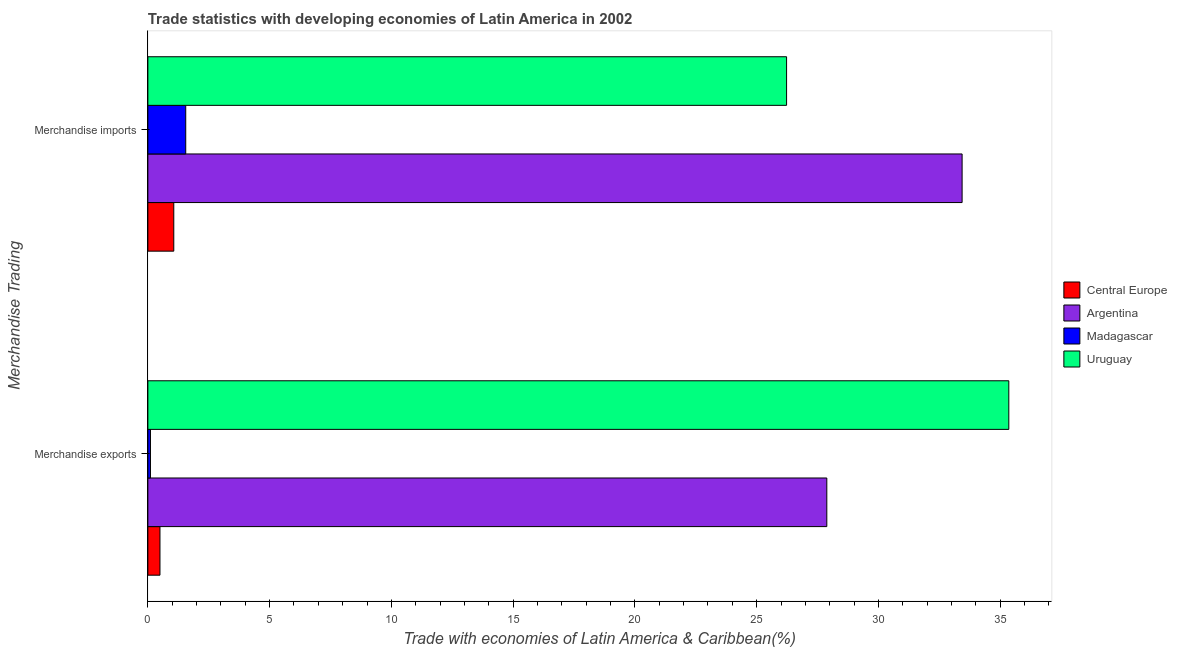How many bars are there on the 1st tick from the bottom?
Provide a short and direct response. 4. What is the label of the 2nd group of bars from the top?
Provide a short and direct response. Merchandise exports. What is the merchandise imports in Central Europe?
Offer a terse response. 1.06. Across all countries, what is the maximum merchandise exports?
Give a very brief answer. 35.35. Across all countries, what is the minimum merchandise exports?
Your answer should be compact. 0.11. In which country was the merchandise exports maximum?
Offer a very short reply. Uruguay. In which country was the merchandise exports minimum?
Give a very brief answer. Madagascar. What is the total merchandise imports in the graph?
Your answer should be compact. 62.28. What is the difference between the merchandise imports in Madagascar and that in Central Europe?
Ensure brevity in your answer.  0.49. What is the difference between the merchandise exports in Argentina and the merchandise imports in Uruguay?
Make the answer very short. 1.65. What is the average merchandise exports per country?
Offer a very short reply. 15.96. What is the difference between the merchandise imports and merchandise exports in Argentina?
Provide a short and direct response. 5.56. What is the ratio of the merchandise imports in Central Europe to that in Argentina?
Your response must be concise. 0.03. Is the merchandise exports in Central Europe less than that in Argentina?
Give a very brief answer. Yes. In how many countries, is the merchandise imports greater than the average merchandise imports taken over all countries?
Keep it short and to the point. 2. What does the 1st bar from the top in Merchandise exports represents?
Provide a short and direct response. Uruguay. What does the 4th bar from the bottom in Merchandise imports represents?
Your response must be concise. Uruguay. How many bars are there?
Your answer should be compact. 8. Are all the bars in the graph horizontal?
Keep it short and to the point. Yes. How many countries are there in the graph?
Make the answer very short. 4. What is the difference between two consecutive major ticks on the X-axis?
Give a very brief answer. 5. Does the graph contain grids?
Ensure brevity in your answer.  No. Where does the legend appear in the graph?
Your answer should be compact. Center right. What is the title of the graph?
Your response must be concise. Trade statistics with developing economies of Latin America in 2002. Does "Sub-Saharan Africa (developing only)" appear as one of the legend labels in the graph?
Offer a terse response. No. What is the label or title of the X-axis?
Offer a terse response. Trade with economies of Latin America & Caribbean(%). What is the label or title of the Y-axis?
Make the answer very short. Merchandise Trading. What is the Trade with economies of Latin America & Caribbean(%) in Central Europe in Merchandise exports?
Your answer should be very brief. 0.5. What is the Trade with economies of Latin America & Caribbean(%) of Argentina in Merchandise exports?
Make the answer very short. 27.88. What is the Trade with economies of Latin America & Caribbean(%) of Madagascar in Merchandise exports?
Make the answer very short. 0.11. What is the Trade with economies of Latin America & Caribbean(%) of Uruguay in Merchandise exports?
Provide a short and direct response. 35.35. What is the Trade with economies of Latin America & Caribbean(%) in Central Europe in Merchandise imports?
Your answer should be very brief. 1.06. What is the Trade with economies of Latin America & Caribbean(%) in Argentina in Merchandise imports?
Provide a short and direct response. 33.44. What is the Trade with economies of Latin America & Caribbean(%) in Madagascar in Merchandise imports?
Offer a terse response. 1.56. What is the Trade with economies of Latin America & Caribbean(%) in Uruguay in Merchandise imports?
Your response must be concise. 26.23. Across all Merchandise Trading, what is the maximum Trade with economies of Latin America & Caribbean(%) of Central Europe?
Offer a very short reply. 1.06. Across all Merchandise Trading, what is the maximum Trade with economies of Latin America & Caribbean(%) of Argentina?
Your response must be concise. 33.44. Across all Merchandise Trading, what is the maximum Trade with economies of Latin America & Caribbean(%) in Madagascar?
Your response must be concise. 1.56. Across all Merchandise Trading, what is the maximum Trade with economies of Latin America & Caribbean(%) of Uruguay?
Your response must be concise. 35.35. Across all Merchandise Trading, what is the minimum Trade with economies of Latin America & Caribbean(%) in Central Europe?
Ensure brevity in your answer.  0.5. Across all Merchandise Trading, what is the minimum Trade with economies of Latin America & Caribbean(%) in Argentina?
Your response must be concise. 27.88. Across all Merchandise Trading, what is the minimum Trade with economies of Latin America & Caribbean(%) of Madagascar?
Your answer should be compact. 0.11. Across all Merchandise Trading, what is the minimum Trade with economies of Latin America & Caribbean(%) in Uruguay?
Your answer should be very brief. 26.23. What is the total Trade with economies of Latin America & Caribbean(%) of Central Europe in the graph?
Make the answer very short. 1.56. What is the total Trade with economies of Latin America & Caribbean(%) in Argentina in the graph?
Provide a succinct answer. 61.32. What is the total Trade with economies of Latin America & Caribbean(%) of Madagascar in the graph?
Make the answer very short. 1.66. What is the total Trade with economies of Latin America & Caribbean(%) of Uruguay in the graph?
Your response must be concise. 61.58. What is the difference between the Trade with economies of Latin America & Caribbean(%) in Central Europe in Merchandise exports and that in Merchandise imports?
Make the answer very short. -0.57. What is the difference between the Trade with economies of Latin America & Caribbean(%) in Argentina in Merchandise exports and that in Merchandise imports?
Keep it short and to the point. -5.56. What is the difference between the Trade with economies of Latin America & Caribbean(%) of Madagascar in Merchandise exports and that in Merchandise imports?
Your response must be concise. -1.45. What is the difference between the Trade with economies of Latin America & Caribbean(%) in Uruguay in Merchandise exports and that in Merchandise imports?
Your response must be concise. 9.13. What is the difference between the Trade with economies of Latin America & Caribbean(%) in Central Europe in Merchandise exports and the Trade with economies of Latin America & Caribbean(%) in Argentina in Merchandise imports?
Your answer should be very brief. -32.94. What is the difference between the Trade with economies of Latin America & Caribbean(%) in Central Europe in Merchandise exports and the Trade with economies of Latin America & Caribbean(%) in Madagascar in Merchandise imports?
Your answer should be very brief. -1.06. What is the difference between the Trade with economies of Latin America & Caribbean(%) in Central Europe in Merchandise exports and the Trade with economies of Latin America & Caribbean(%) in Uruguay in Merchandise imports?
Offer a very short reply. -25.73. What is the difference between the Trade with economies of Latin America & Caribbean(%) of Argentina in Merchandise exports and the Trade with economies of Latin America & Caribbean(%) of Madagascar in Merchandise imports?
Offer a terse response. 26.32. What is the difference between the Trade with economies of Latin America & Caribbean(%) in Argentina in Merchandise exports and the Trade with economies of Latin America & Caribbean(%) in Uruguay in Merchandise imports?
Your answer should be very brief. 1.65. What is the difference between the Trade with economies of Latin America & Caribbean(%) of Madagascar in Merchandise exports and the Trade with economies of Latin America & Caribbean(%) of Uruguay in Merchandise imports?
Your answer should be very brief. -26.12. What is the average Trade with economies of Latin America & Caribbean(%) in Central Europe per Merchandise Trading?
Give a very brief answer. 0.78. What is the average Trade with economies of Latin America & Caribbean(%) of Argentina per Merchandise Trading?
Your response must be concise. 30.66. What is the average Trade with economies of Latin America & Caribbean(%) of Madagascar per Merchandise Trading?
Offer a terse response. 0.83. What is the average Trade with economies of Latin America & Caribbean(%) of Uruguay per Merchandise Trading?
Make the answer very short. 30.79. What is the difference between the Trade with economies of Latin America & Caribbean(%) of Central Europe and Trade with economies of Latin America & Caribbean(%) of Argentina in Merchandise exports?
Make the answer very short. -27.38. What is the difference between the Trade with economies of Latin America & Caribbean(%) in Central Europe and Trade with economies of Latin America & Caribbean(%) in Madagascar in Merchandise exports?
Offer a terse response. 0.39. What is the difference between the Trade with economies of Latin America & Caribbean(%) of Central Europe and Trade with economies of Latin America & Caribbean(%) of Uruguay in Merchandise exports?
Give a very brief answer. -34.86. What is the difference between the Trade with economies of Latin America & Caribbean(%) of Argentina and Trade with economies of Latin America & Caribbean(%) of Madagascar in Merchandise exports?
Offer a very short reply. 27.77. What is the difference between the Trade with economies of Latin America & Caribbean(%) of Argentina and Trade with economies of Latin America & Caribbean(%) of Uruguay in Merchandise exports?
Offer a very short reply. -7.47. What is the difference between the Trade with economies of Latin America & Caribbean(%) of Madagascar and Trade with economies of Latin America & Caribbean(%) of Uruguay in Merchandise exports?
Provide a succinct answer. -35.25. What is the difference between the Trade with economies of Latin America & Caribbean(%) in Central Europe and Trade with economies of Latin America & Caribbean(%) in Argentina in Merchandise imports?
Make the answer very short. -32.37. What is the difference between the Trade with economies of Latin America & Caribbean(%) of Central Europe and Trade with economies of Latin America & Caribbean(%) of Madagascar in Merchandise imports?
Make the answer very short. -0.49. What is the difference between the Trade with economies of Latin America & Caribbean(%) of Central Europe and Trade with economies of Latin America & Caribbean(%) of Uruguay in Merchandise imports?
Offer a very short reply. -25.16. What is the difference between the Trade with economies of Latin America & Caribbean(%) of Argentina and Trade with economies of Latin America & Caribbean(%) of Madagascar in Merchandise imports?
Your response must be concise. 31.88. What is the difference between the Trade with economies of Latin America & Caribbean(%) in Argentina and Trade with economies of Latin America & Caribbean(%) in Uruguay in Merchandise imports?
Your response must be concise. 7.21. What is the difference between the Trade with economies of Latin America & Caribbean(%) in Madagascar and Trade with economies of Latin America & Caribbean(%) in Uruguay in Merchandise imports?
Provide a short and direct response. -24.67. What is the ratio of the Trade with economies of Latin America & Caribbean(%) in Central Europe in Merchandise exports to that in Merchandise imports?
Keep it short and to the point. 0.47. What is the ratio of the Trade with economies of Latin America & Caribbean(%) in Argentina in Merchandise exports to that in Merchandise imports?
Make the answer very short. 0.83. What is the ratio of the Trade with economies of Latin America & Caribbean(%) of Madagascar in Merchandise exports to that in Merchandise imports?
Your answer should be compact. 0.07. What is the ratio of the Trade with economies of Latin America & Caribbean(%) of Uruguay in Merchandise exports to that in Merchandise imports?
Your answer should be compact. 1.35. What is the difference between the highest and the second highest Trade with economies of Latin America & Caribbean(%) of Central Europe?
Offer a terse response. 0.57. What is the difference between the highest and the second highest Trade with economies of Latin America & Caribbean(%) in Argentina?
Your answer should be very brief. 5.56. What is the difference between the highest and the second highest Trade with economies of Latin America & Caribbean(%) of Madagascar?
Your answer should be very brief. 1.45. What is the difference between the highest and the second highest Trade with economies of Latin America & Caribbean(%) of Uruguay?
Ensure brevity in your answer.  9.13. What is the difference between the highest and the lowest Trade with economies of Latin America & Caribbean(%) of Central Europe?
Offer a terse response. 0.57. What is the difference between the highest and the lowest Trade with economies of Latin America & Caribbean(%) of Argentina?
Keep it short and to the point. 5.56. What is the difference between the highest and the lowest Trade with economies of Latin America & Caribbean(%) of Madagascar?
Provide a succinct answer. 1.45. What is the difference between the highest and the lowest Trade with economies of Latin America & Caribbean(%) of Uruguay?
Provide a succinct answer. 9.13. 